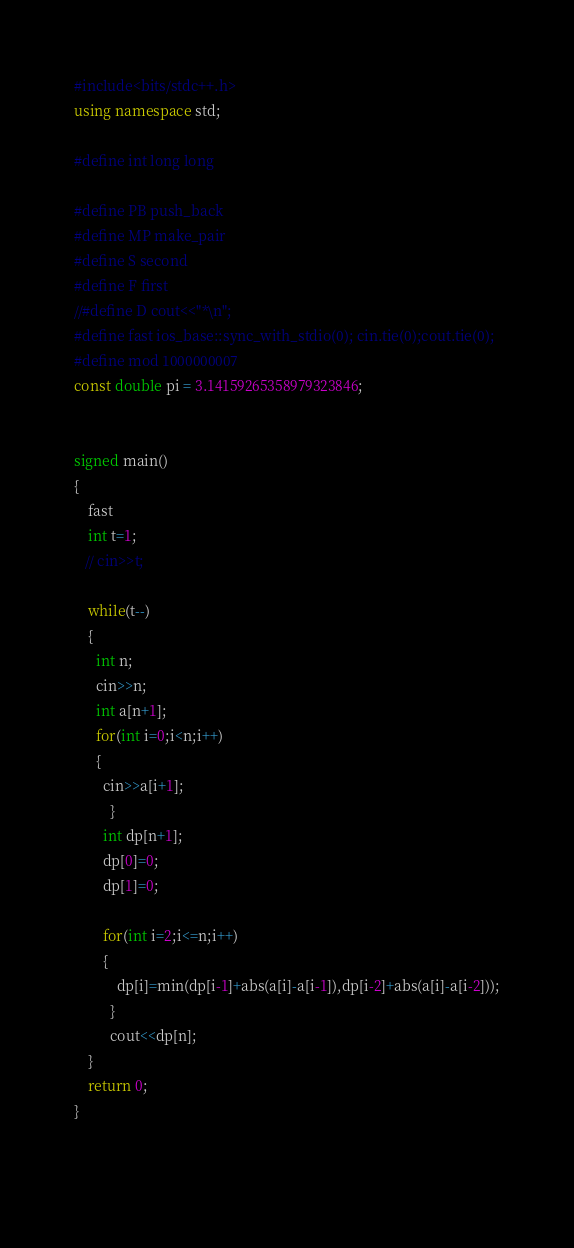Convert code to text. <code><loc_0><loc_0><loc_500><loc_500><_C++_>#include<bits/stdc++.h>
using namespace std;
 
#define int long long
 
#define PB push_back
#define MP make_pair
#define S second
#define F first
//#define D cout<<"*\n";
#define fast ios_base::sync_with_stdio(0); cin.tie(0);cout.tie(0);
#define mod 1000000007 
const double pi = 3.14159265358979323846; 


signed main()
{
    fast
    int t=1;
   // cin>>t;
    
    while(t--)
    {
      int n;
	  cin>>n;
	  int a[n+1];
	  for(int i=0;i<n;i++)
	  {
	  	cin>>a[i+1];
		  }	
		int dp[n+1];
		dp[0]=0;
		dp[1]=0;
		
		for(int i=2;i<=n;i++)
		{
			dp[i]=min(dp[i-1]+abs(a[i]-a[i-1]),dp[i-2]+abs(a[i]-a[i-2]));
		  }  
		  cout<<dp[n];
    }
	return 0;
}

	</code> 